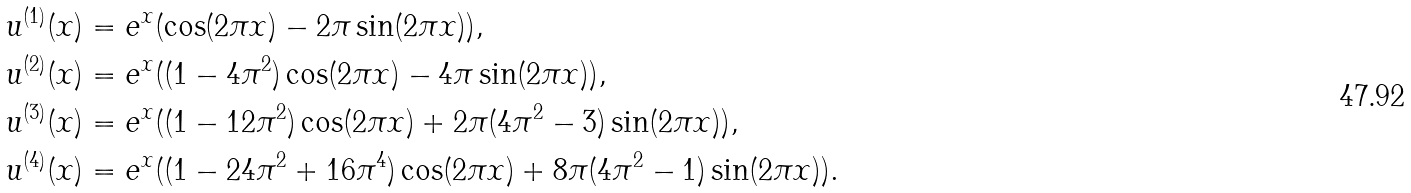Convert formula to latex. <formula><loc_0><loc_0><loc_500><loc_500>u ^ { ( 1 ) } ( x ) & = e ^ { x } ( \cos ( 2 \pi x ) - 2 \pi \sin ( 2 \pi x ) ) , \\ u ^ { ( 2 ) } ( x ) & = e ^ { x } ( ( 1 - 4 \pi ^ { 2 } ) \cos ( 2 \pi x ) - 4 \pi \sin ( 2 \pi x ) ) , \\ u ^ { ( 3 ) } ( x ) & = e ^ { x } ( ( 1 - 1 2 \pi ^ { 2 } ) \cos ( 2 \pi x ) + 2 \pi ( 4 \pi ^ { 2 } - 3 ) \sin ( 2 \pi x ) ) , \\ u ^ { ( 4 ) } ( x ) & = e ^ { x } ( ( 1 - 2 4 \pi ^ { 2 } + 1 6 \pi ^ { 4 } ) \cos ( 2 \pi x ) + 8 \pi ( 4 \pi ^ { 2 } - 1 ) \sin ( 2 \pi x ) ) .</formula> 